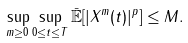<formula> <loc_0><loc_0><loc_500><loc_500>\sup _ { m \geq 0 } \sup _ { 0 \leq t \leq T } \bar { \mathbb { E } } [ | X ^ { m } ( t ) | ^ { p } ] & \leq M .</formula> 